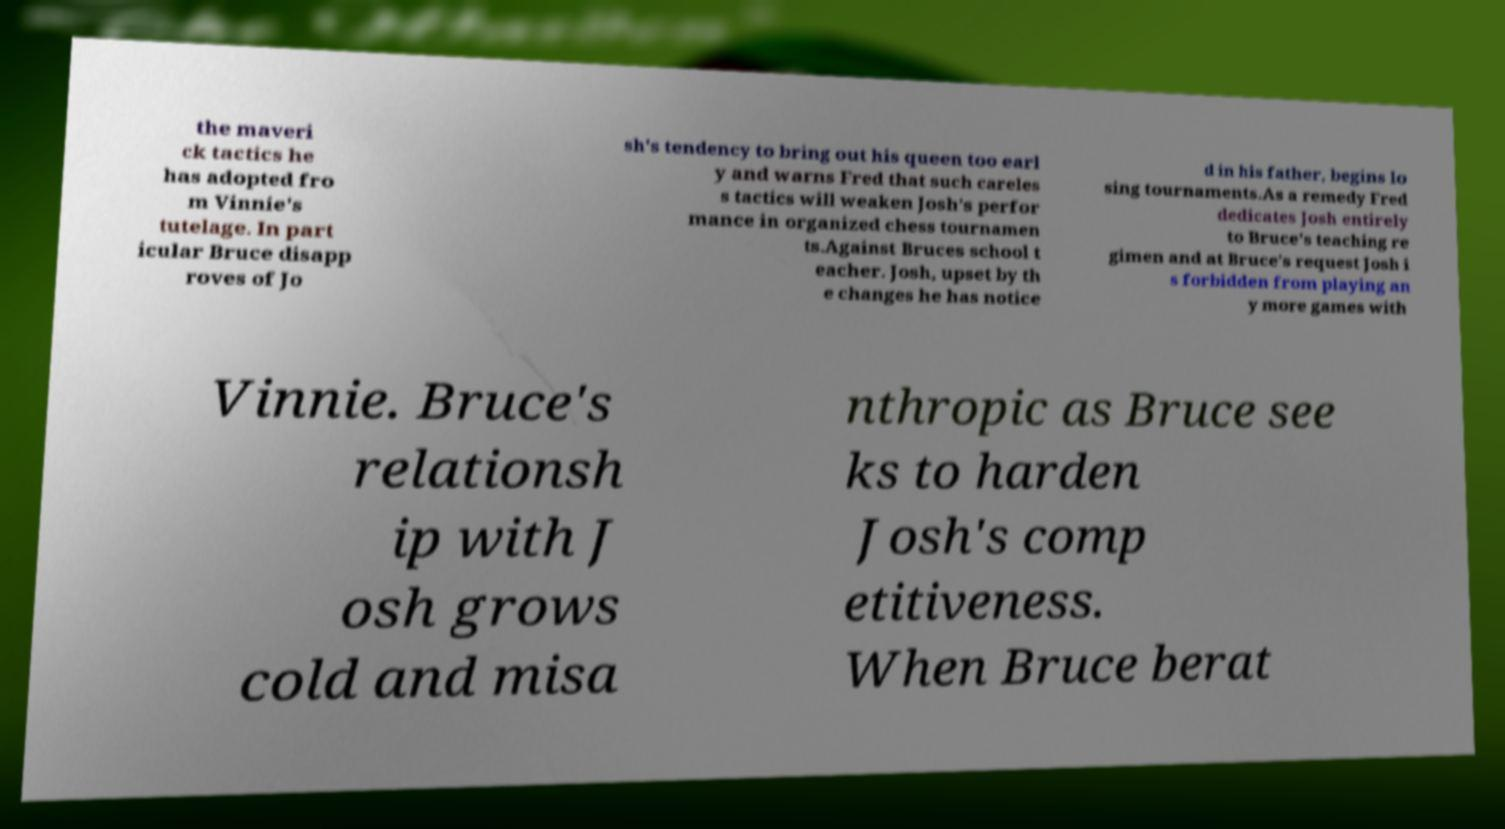Could you extract and type out the text from this image? the maveri ck tactics he has adopted fro m Vinnie's tutelage. In part icular Bruce disapp roves of Jo sh's tendency to bring out his queen too earl y and warns Fred that such careles s tactics will weaken Josh's perfor mance in organized chess tournamen ts.Against Bruces school t eacher. Josh, upset by th e changes he has notice d in his father, begins lo sing tournaments.As a remedy Fred dedicates Josh entirely to Bruce's teaching re gimen and at Bruce's request Josh i s forbidden from playing an y more games with Vinnie. Bruce's relationsh ip with J osh grows cold and misa nthropic as Bruce see ks to harden Josh's comp etitiveness. When Bruce berat 